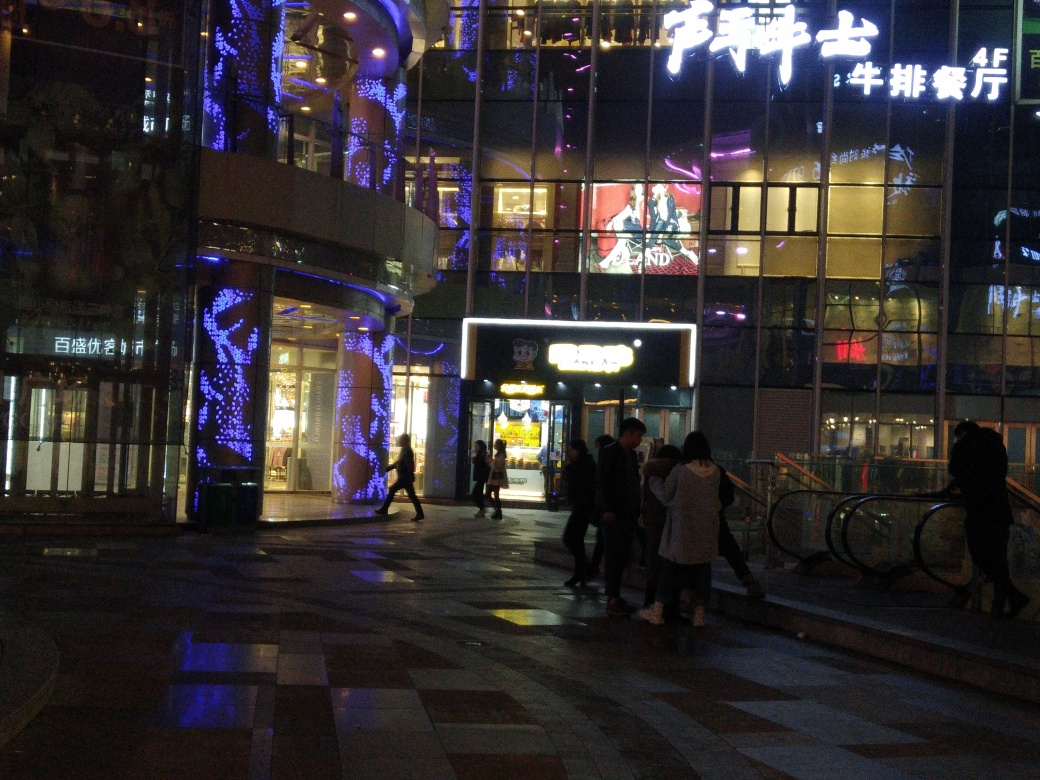What does this image suggest about the location? This image appears to be taken in an urban commercial district during the evening. The presence of bright signage, illuminated advertisements, and a diverse array of lighting decorations indicates a place that is lively and possibly a hub for shopping or entertainment, catering to pedestrians and consumers. 